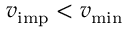<formula> <loc_0><loc_0><loc_500><loc_500>v _ { i m p } < v _ { \min }</formula> 